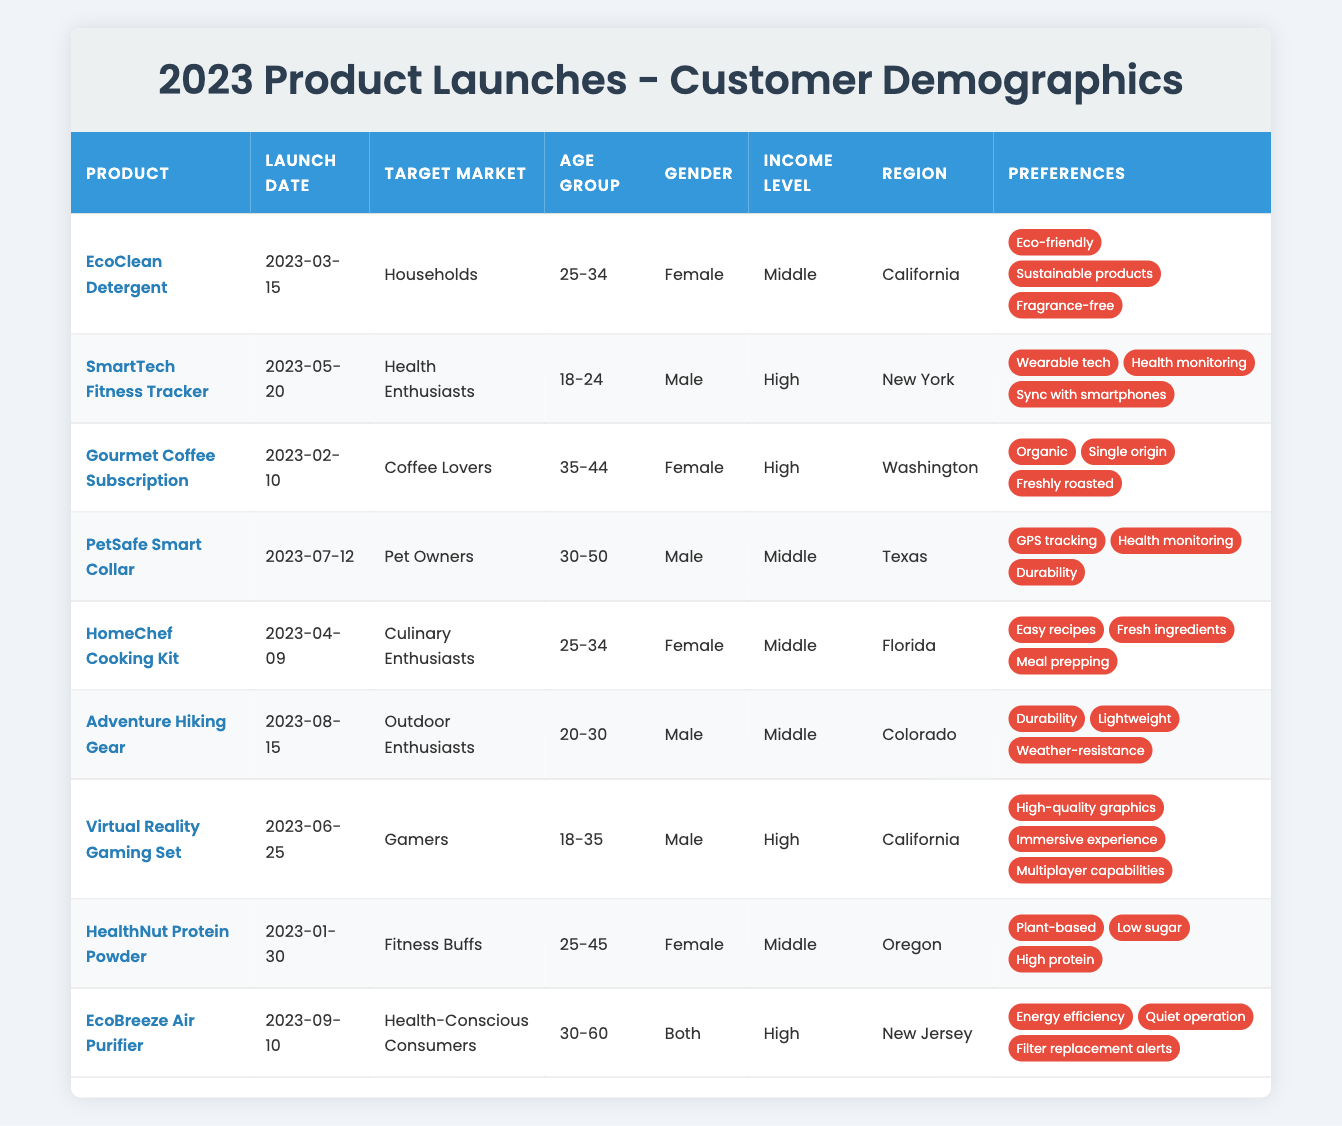What is the launch date of the EcoClean Detergent? The launch date is explicitly listed in the table under the "Launch Date" column next to the EcoClean Detergent. It shows "2023-03-15."
Answer: 2023-03-15 How many products target health enthusiasts? By scanning the "Target Market" column, we find one product specifically targeting health enthusiasts, which is the SmartTech Fitness Tracker.
Answer: 1 Which product has the highest income level target? Referencing the "Income Level" column, there are three products targeting a "High" income level: SmartTech Fitness Tracker, Gourmet Coffee Subscription, and Virtual Reality Gaming Set, indicating this as the highest income category available.
Answer: 3 Is the target market for EcoBreeze Air Purifier both restricted to a specific gender? The "Gender" column shows that EcoBreeze Air Purifier targets "Both" genders, indicating it is not restricted to a specific gender.
Answer: No Which product has preferences related to durability and weather-resistance? Looking under the "Preferences" column for the products, Adventure Hiking Gear lists "Durability" and "Weather-resistance" as part of its features.
Answer: Adventure Hiking Gear How many products are aimed at both males and females? In the "Gender" column, only the EcoBreeze Air Purifier is listed as targeting "Both," verifying that it is the only product aimed at both genders.
Answer: 1 What is the average age group for products targeting males? Extracting the “Age Group” data for the male-targeted products: SmartTech Fitness Tracker (18-24), PetSafe Smart Collar (30-50), Adventure Hiking Gear (20-30), and Virtual Reality Gaming Set (18-35). The ranges (18-24, 20-30, and 18-35 averages to about 24.5) and (30-50, averaging to 40). Combining them gives (24.5 + 40) / 4 = 32.25, on average.
Answer: 32.25 Which region has the most diverse product launches based on the provided data? Reviewing the "Region" column, we identify California, New York, Washington, Texas, Florida, Colorado, Oregon, and New Jersey as the regions for different products. California and New York each have two products, while the others have one, making California most diverse.
Answer: California How many products launched before June 2023? By checking the "Launch Date," we find that 6 products (January through May dates) launched before June 2023, including HealthNut Protein Powder, Gourmet Coffee Subscription, and others up to HomeChef Cooking Kit.
Answer: 6 Do any products intended for outdoor enthusiasts also target a specific age group? Checking the "Age Group" of Adventure Hiking Gear, which targets "20-30," we confirm that it is indeed intended for a specific age group.
Answer: Yes 